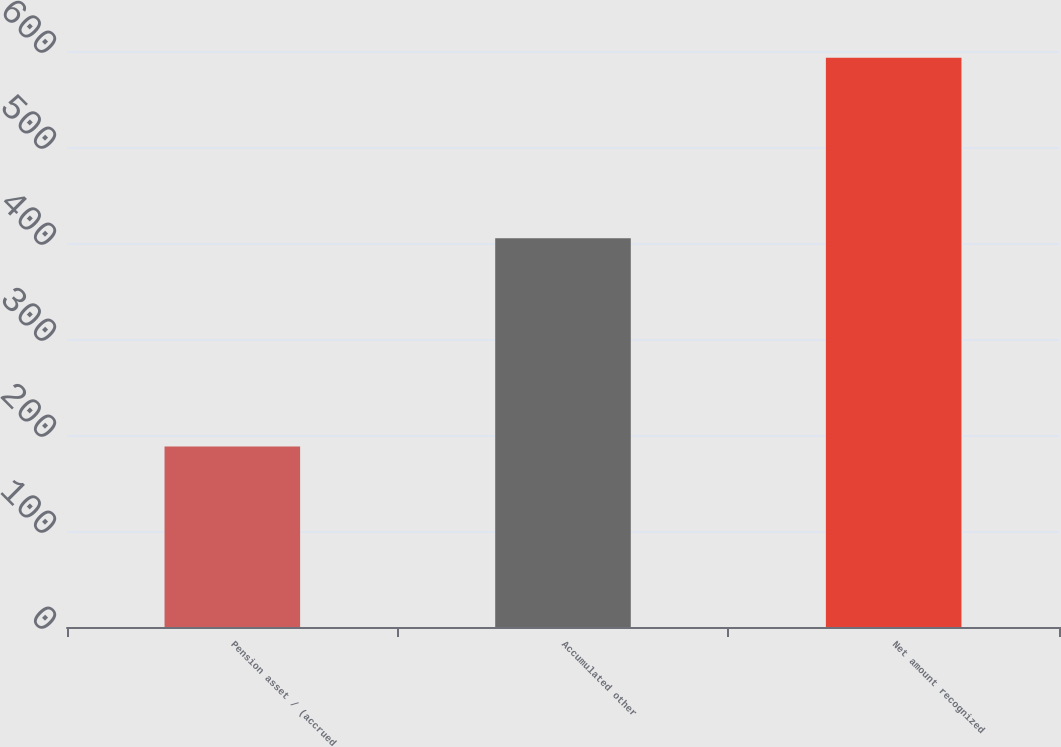<chart> <loc_0><loc_0><loc_500><loc_500><bar_chart><fcel>Pension asset / (accrued<fcel>Accumulated other<fcel>Net amount recognized<nl><fcel>188<fcel>405<fcel>593<nl></chart> 